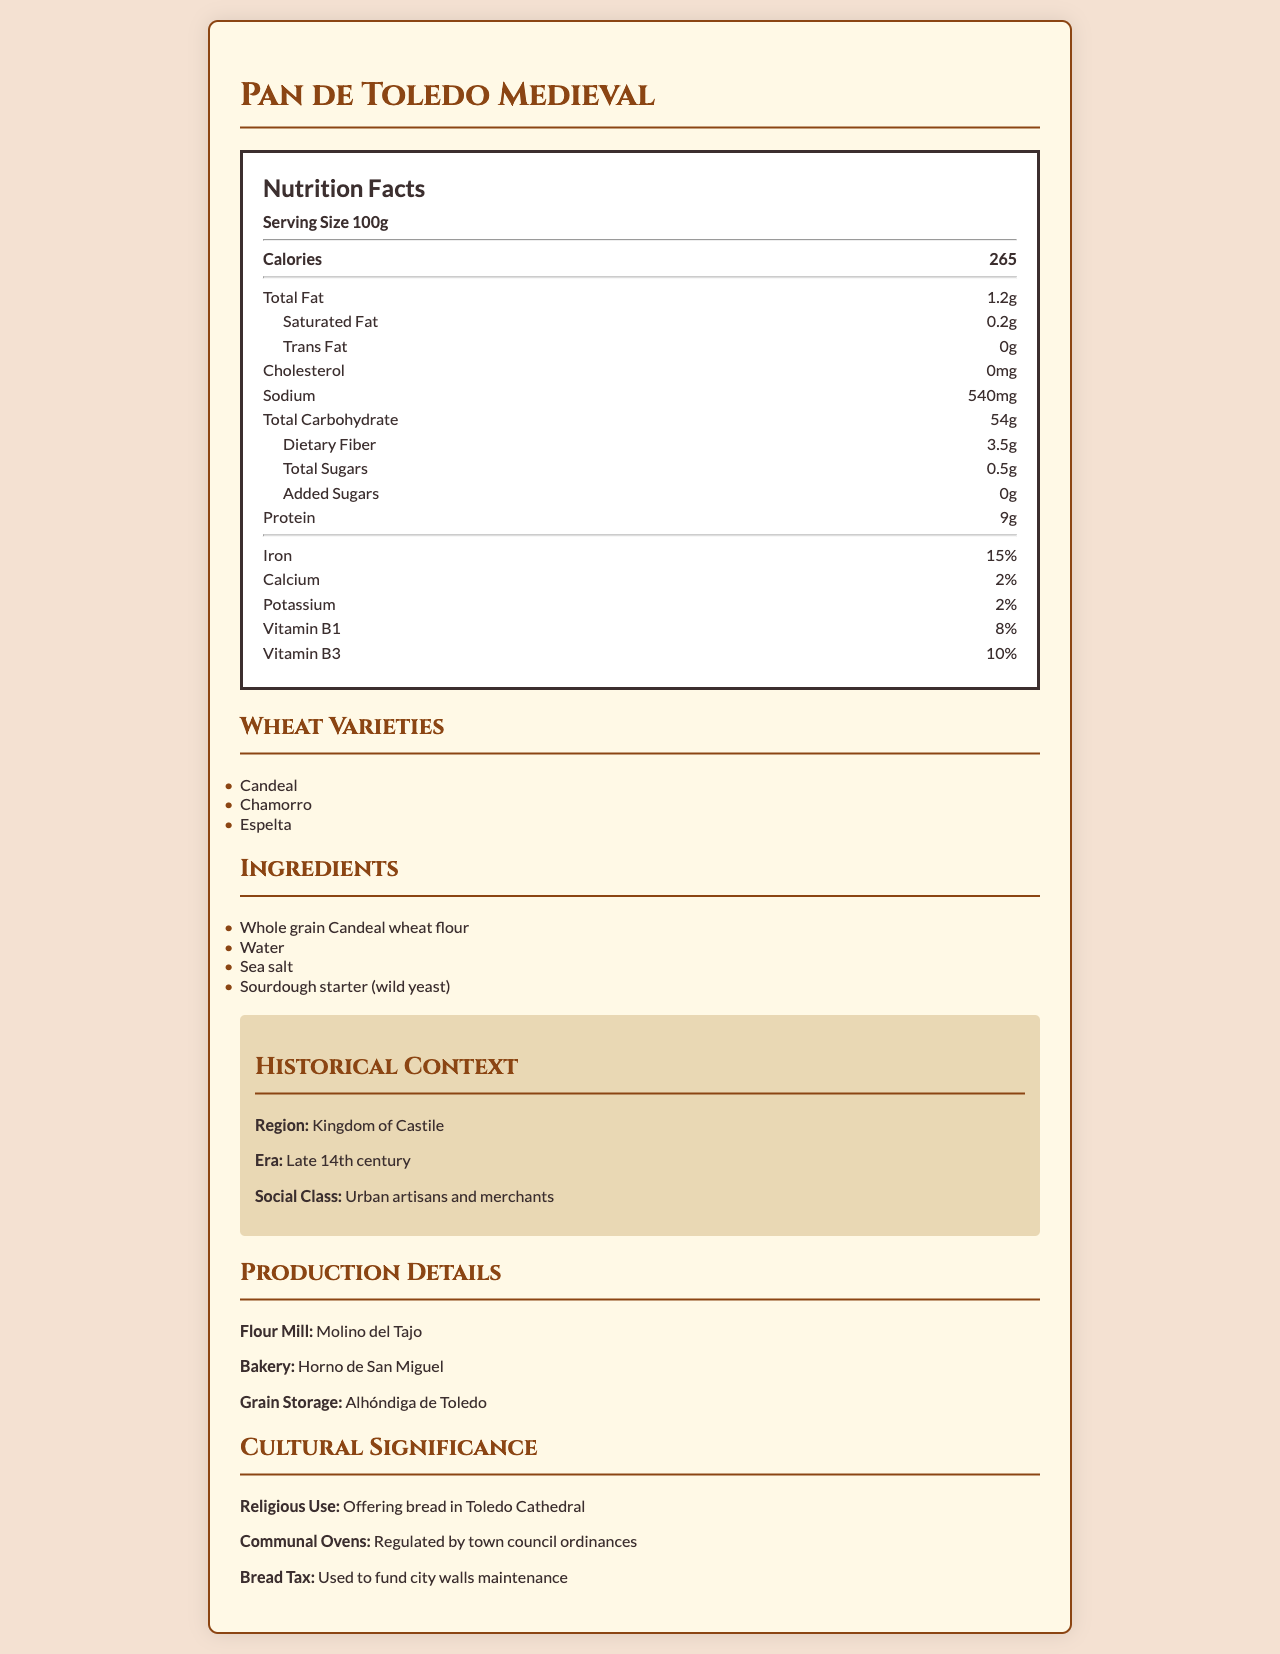What is the serving size of "Pan de Toledo Medieval"? The document specifies the serving size directly under the "Nutrition Facts" header.
Answer: 100g Which wheat varieties are used to make "Pan de Toledo Medieval"? The wheat varieties are listed in a section titled "Wheat Varieties."
Answer: Candeal, Chamorro, Espelta How many calories are in a serving of "Pan de Toledo Medieval"? The number of calories is listed under the "Nutrition Facts" header.
Answer: 265 What is the total carbohydrate content per serving? The total carbohydrate content per serving is explicitly mentioned in the "Nutrition Facts" section.
Answer: 54g What is the main baking method used for "Pan de Toledo Medieval"? The baking method is mentioned along with other production details in the document.
Answer: Stone oven-baked How much dietary fiber is in a serving of this bread? The dietary fiber content is found in the "Nutrition Facts" section.
Answer: 3.5g What is the percentage of daily iron provided by a serving of "Pan de Toledo Medieval"? The percentage of daily iron is listed under vitamins and minerals in the "Nutrition Facts" section.
Answer: 15% Which of the following ingredients is NOT used in "Pan de Toledo Medieval"? A. Whole grain Candeal wheat flour B. Sugar C. Sea salt D. Sourdough starter The listed ingredients are Whole grain Candeal wheat flour, Water, Sea salt, and Sourdough starter. Sugar is not included.
Answer: B In which region and era was "Pan de Toledo Medieval" predominantly consumed? A. Kingdom of Aragon, Early 15th century B. Kingdom of Castile, Late 14th century C. Kingdom of Leon, Late 13th century The historical context section specifies Kingdom of Castile, Late 14th century.
Answer: B Is there cholesterol in "Pan de Toledo Medieval"? The nutritional content specifies 0 mg of cholesterol.
Answer: No Summarize the main idea of the document. The document is a detailed presentation of various facets of the medieval Spanish bread "Pan de Toledo Medieval," covering multiple aspects from nutrition to historical and cultural importance.
Answer: The document provides comprehensive information about "Pan de Toledo Medieval," including its nutritional content, ingredients, wheat varieties, historical context, production details, and cultural significance. Where was the grain for "Pan de Toledo Medieval" stored? The "production details" section lists Alhóndiga de Toledo as the grain storage facility.
Answer: Alhóndiga de Toledo Which vitamin is present in the highest percentage in "Pan de Toledo Medieval"? The document lists vitamin percentages, and Vitamin B3 is present in the highest percentage at 10%.
Answer: Vitamin B3 (10%) What was the bread tax used to fund? The "cultural significance" section specifies that the bread tax was used to fund city walls maintenance.
Answer: City walls maintenance Was "Pan de Toledo Medieval" used for religious purposes? The document mentions its use as an offering bread in Toledo Cathedral.
Answer: Yes What was the name of the bakery where "Pan de Toledo Medieval" was made? The production details list Horno de San Miguel as the bakery.
Answer: Horno de San Miguel What is the percentage of calcium provided by "Pan de Toledo Medieval"? The Nutrition Facts section lists 2% as the calcium content.
Answer: 2% Which social class predominantly consumed "Pan de Toledo Medieval"? The historical context specifies that urban artisans and merchants predominantly consumed this bread.
Answer: Urban artisans and merchants Was the document generated using a specific code? The document does not provide any information on the code or methods used for its creation; it purely contains historical and nutritional details about the bread.
Answer: Cannot be determined 